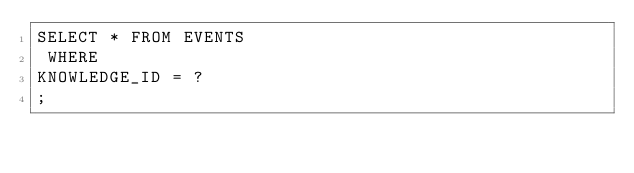<code> <loc_0><loc_0><loc_500><loc_500><_SQL_>SELECT * FROM EVENTS
 WHERE 
KNOWLEDGE_ID = ?
;
</code> 